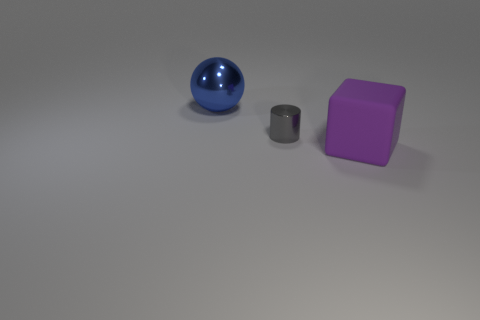There is a big object in front of the object left of the gray metallic thing; what is its material? The large purple object, which appears to be a cube, in front of the object to the left of the gray cylindrical shape, seems to have a matte finish. The precise material is not easily determinable from the image alone, but it could potentially be made of plastic or painted wood, judging by its appearance and common usage for such shapes and finishes. 